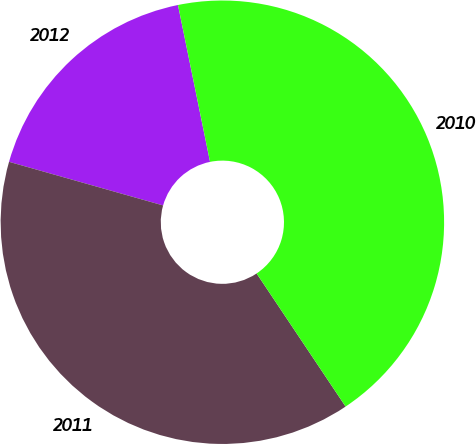<chart> <loc_0><loc_0><loc_500><loc_500><pie_chart><fcel>2012<fcel>2011<fcel>2010<nl><fcel>17.4%<fcel>38.77%<fcel>43.83%<nl></chart> 